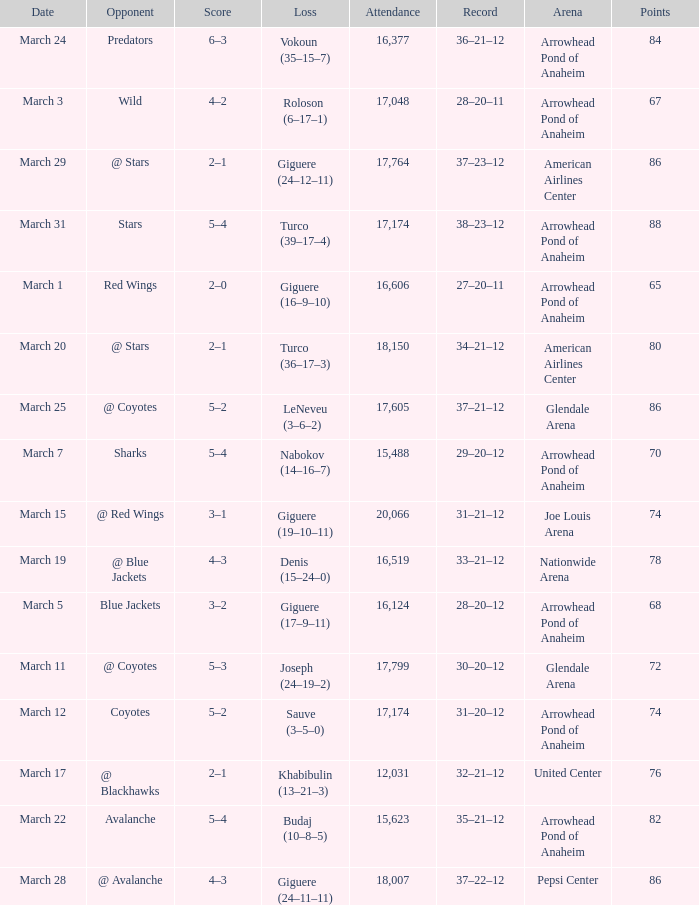What is the Loss of the game at Nationwide Arena with a Score of 4–3? Denis (15–24–0). 